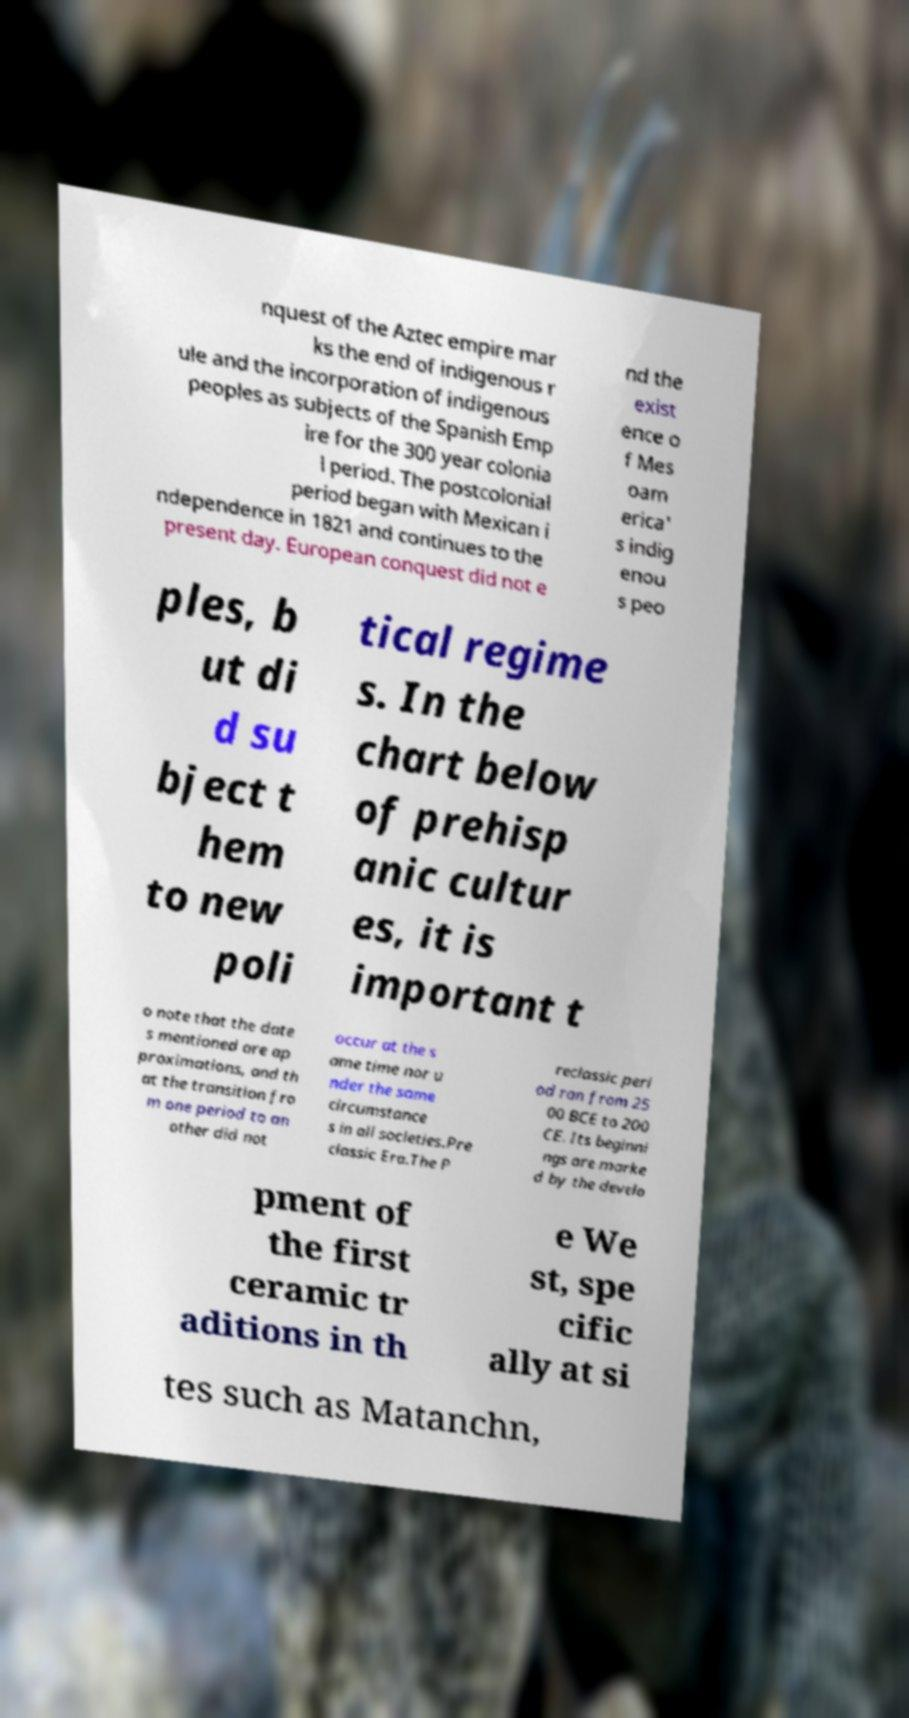There's text embedded in this image that I need extracted. Can you transcribe it verbatim? nquest of the Aztec empire mar ks the end of indigenous r ule and the incorporation of indigenous peoples as subjects of the Spanish Emp ire for the 300 year colonia l period. The postcolonial period began with Mexican i ndependence in 1821 and continues to the present day. European conquest did not e nd the exist ence o f Mes oam erica' s indig enou s peo ples, b ut di d su bject t hem to new poli tical regime s. In the chart below of prehisp anic cultur es, it is important t o note that the date s mentioned are ap proximations, and th at the transition fro m one period to an other did not occur at the s ame time nor u nder the same circumstance s in all societies.Pre classic Era.The P reclassic peri od ran from 25 00 BCE to 200 CE. Its beginni ngs are marke d by the develo pment of the first ceramic tr aditions in th e We st, spe cific ally at si tes such as Matanchn, 